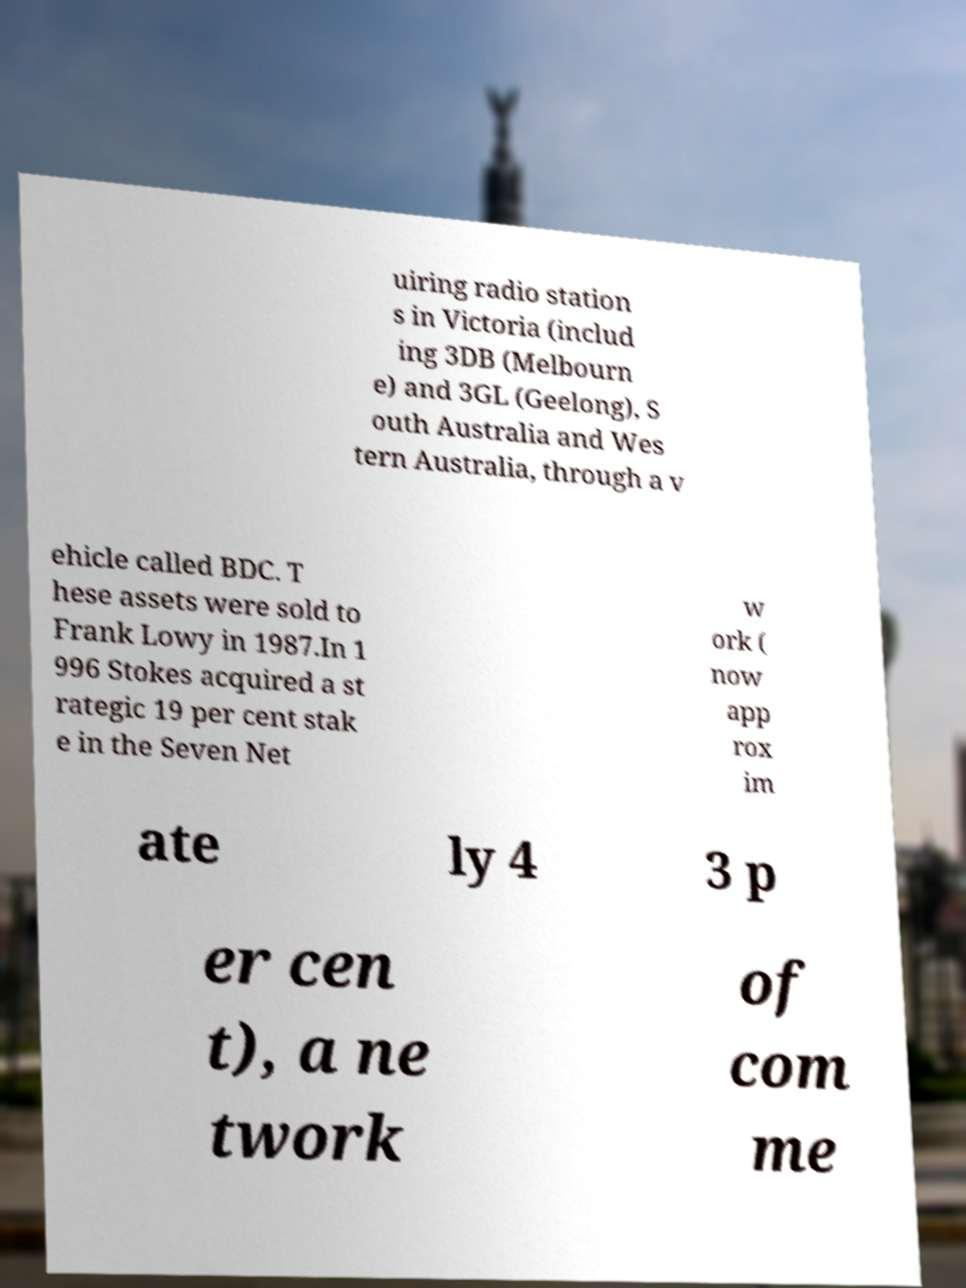What messages or text are displayed in this image? I need them in a readable, typed format. uiring radio station s in Victoria (includ ing 3DB (Melbourn e) and 3GL (Geelong), S outh Australia and Wes tern Australia, through a v ehicle called BDC. T hese assets were sold to Frank Lowy in 1987.In 1 996 Stokes acquired a st rategic 19 per cent stak e in the Seven Net w ork ( now app rox im ate ly 4 3 p er cen t), a ne twork of com me 